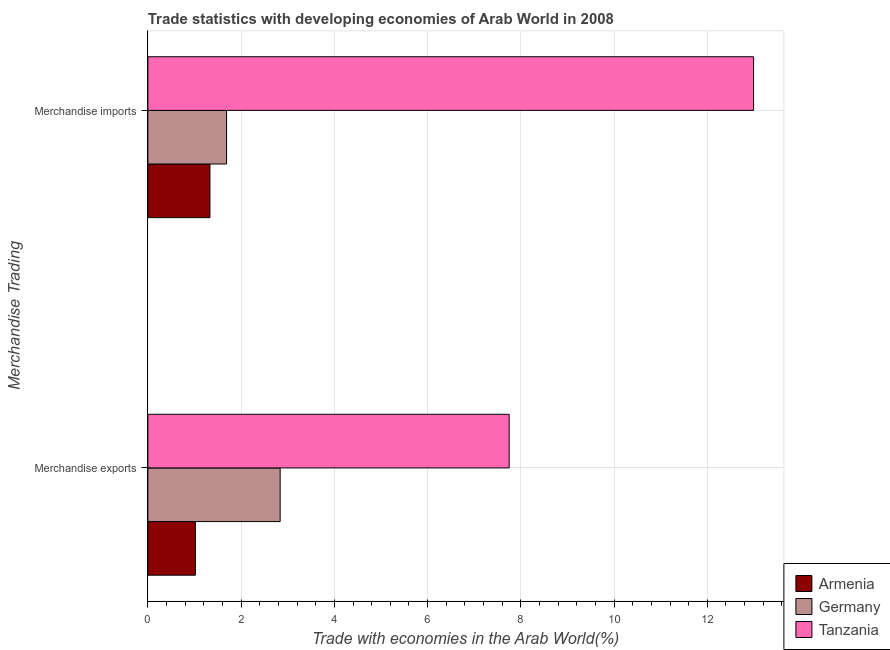How many different coloured bars are there?
Offer a terse response. 3. How many groups of bars are there?
Offer a very short reply. 2. How many bars are there on the 1st tick from the top?
Offer a very short reply. 3. How many bars are there on the 2nd tick from the bottom?
Ensure brevity in your answer.  3. What is the merchandise imports in Tanzania?
Provide a succinct answer. 12.99. Across all countries, what is the maximum merchandise imports?
Provide a succinct answer. 12.99. Across all countries, what is the minimum merchandise exports?
Keep it short and to the point. 1.02. In which country was the merchandise imports maximum?
Make the answer very short. Tanzania. In which country was the merchandise imports minimum?
Provide a succinct answer. Armenia. What is the total merchandise imports in the graph?
Your answer should be very brief. 16.01. What is the difference between the merchandise exports in Tanzania and that in Armenia?
Your answer should be very brief. 6.73. What is the difference between the merchandise exports in Armenia and the merchandise imports in Germany?
Offer a terse response. -0.67. What is the average merchandise exports per country?
Provide a short and direct response. 3.87. What is the difference between the merchandise exports and merchandise imports in Tanzania?
Your answer should be compact. -5.24. What is the ratio of the merchandise exports in Armenia to that in Germany?
Offer a very short reply. 0.36. Is the merchandise imports in Tanzania less than that in Armenia?
Your answer should be compact. No. What does the 1st bar from the bottom in Merchandise exports represents?
Keep it short and to the point. Armenia. How many countries are there in the graph?
Your response must be concise. 3. Are the values on the major ticks of X-axis written in scientific E-notation?
Your answer should be very brief. No. Does the graph contain any zero values?
Offer a very short reply. No. Does the graph contain grids?
Provide a succinct answer. Yes. How many legend labels are there?
Make the answer very short. 3. What is the title of the graph?
Keep it short and to the point. Trade statistics with developing economies of Arab World in 2008. Does "Tanzania" appear as one of the legend labels in the graph?
Give a very brief answer. Yes. What is the label or title of the X-axis?
Your response must be concise. Trade with economies in the Arab World(%). What is the label or title of the Y-axis?
Your answer should be very brief. Merchandise Trading. What is the Trade with economies in the Arab World(%) in Armenia in Merchandise exports?
Your answer should be compact. 1.02. What is the Trade with economies in the Arab World(%) of Germany in Merchandise exports?
Provide a succinct answer. 2.84. What is the Trade with economies in the Arab World(%) in Tanzania in Merchandise exports?
Keep it short and to the point. 7.75. What is the Trade with economies in the Arab World(%) of Armenia in Merchandise imports?
Make the answer very short. 1.33. What is the Trade with economies in the Arab World(%) in Germany in Merchandise imports?
Your answer should be compact. 1.69. What is the Trade with economies in the Arab World(%) of Tanzania in Merchandise imports?
Offer a very short reply. 12.99. Across all Merchandise Trading, what is the maximum Trade with economies in the Arab World(%) of Armenia?
Make the answer very short. 1.33. Across all Merchandise Trading, what is the maximum Trade with economies in the Arab World(%) in Germany?
Keep it short and to the point. 2.84. Across all Merchandise Trading, what is the maximum Trade with economies in the Arab World(%) of Tanzania?
Provide a succinct answer. 12.99. Across all Merchandise Trading, what is the minimum Trade with economies in the Arab World(%) of Armenia?
Offer a very short reply. 1.02. Across all Merchandise Trading, what is the minimum Trade with economies in the Arab World(%) of Germany?
Give a very brief answer. 1.69. Across all Merchandise Trading, what is the minimum Trade with economies in the Arab World(%) of Tanzania?
Make the answer very short. 7.75. What is the total Trade with economies in the Arab World(%) of Armenia in the graph?
Your answer should be compact. 2.35. What is the total Trade with economies in the Arab World(%) of Germany in the graph?
Give a very brief answer. 4.53. What is the total Trade with economies in the Arab World(%) in Tanzania in the graph?
Your answer should be compact. 20.74. What is the difference between the Trade with economies in the Arab World(%) of Armenia in Merchandise exports and that in Merchandise imports?
Give a very brief answer. -0.31. What is the difference between the Trade with economies in the Arab World(%) of Germany in Merchandise exports and that in Merchandise imports?
Your answer should be compact. 1.15. What is the difference between the Trade with economies in the Arab World(%) of Tanzania in Merchandise exports and that in Merchandise imports?
Keep it short and to the point. -5.24. What is the difference between the Trade with economies in the Arab World(%) in Armenia in Merchandise exports and the Trade with economies in the Arab World(%) in Germany in Merchandise imports?
Give a very brief answer. -0.67. What is the difference between the Trade with economies in the Arab World(%) of Armenia in Merchandise exports and the Trade with economies in the Arab World(%) of Tanzania in Merchandise imports?
Provide a succinct answer. -11.97. What is the difference between the Trade with economies in the Arab World(%) of Germany in Merchandise exports and the Trade with economies in the Arab World(%) of Tanzania in Merchandise imports?
Make the answer very short. -10.15. What is the average Trade with economies in the Arab World(%) of Armenia per Merchandise Trading?
Your answer should be very brief. 1.18. What is the average Trade with economies in the Arab World(%) in Germany per Merchandise Trading?
Your answer should be very brief. 2.26. What is the average Trade with economies in the Arab World(%) of Tanzania per Merchandise Trading?
Provide a short and direct response. 10.37. What is the difference between the Trade with economies in the Arab World(%) of Armenia and Trade with economies in the Arab World(%) of Germany in Merchandise exports?
Make the answer very short. -1.82. What is the difference between the Trade with economies in the Arab World(%) of Armenia and Trade with economies in the Arab World(%) of Tanzania in Merchandise exports?
Make the answer very short. -6.73. What is the difference between the Trade with economies in the Arab World(%) of Germany and Trade with economies in the Arab World(%) of Tanzania in Merchandise exports?
Your response must be concise. -4.91. What is the difference between the Trade with economies in the Arab World(%) in Armenia and Trade with economies in the Arab World(%) in Germany in Merchandise imports?
Keep it short and to the point. -0.36. What is the difference between the Trade with economies in the Arab World(%) in Armenia and Trade with economies in the Arab World(%) in Tanzania in Merchandise imports?
Provide a short and direct response. -11.66. What is the difference between the Trade with economies in the Arab World(%) of Germany and Trade with economies in the Arab World(%) of Tanzania in Merchandise imports?
Offer a terse response. -11.3. What is the ratio of the Trade with economies in the Arab World(%) of Armenia in Merchandise exports to that in Merchandise imports?
Give a very brief answer. 0.77. What is the ratio of the Trade with economies in the Arab World(%) in Germany in Merchandise exports to that in Merchandise imports?
Offer a terse response. 1.68. What is the ratio of the Trade with economies in the Arab World(%) of Tanzania in Merchandise exports to that in Merchandise imports?
Offer a very short reply. 0.6. What is the difference between the highest and the second highest Trade with economies in the Arab World(%) in Armenia?
Make the answer very short. 0.31. What is the difference between the highest and the second highest Trade with economies in the Arab World(%) of Germany?
Your answer should be compact. 1.15. What is the difference between the highest and the second highest Trade with economies in the Arab World(%) in Tanzania?
Provide a short and direct response. 5.24. What is the difference between the highest and the lowest Trade with economies in the Arab World(%) in Armenia?
Make the answer very short. 0.31. What is the difference between the highest and the lowest Trade with economies in the Arab World(%) in Germany?
Your answer should be very brief. 1.15. What is the difference between the highest and the lowest Trade with economies in the Arab World(%) of Tanzania?
Your answer should be very brief. 5.24. 